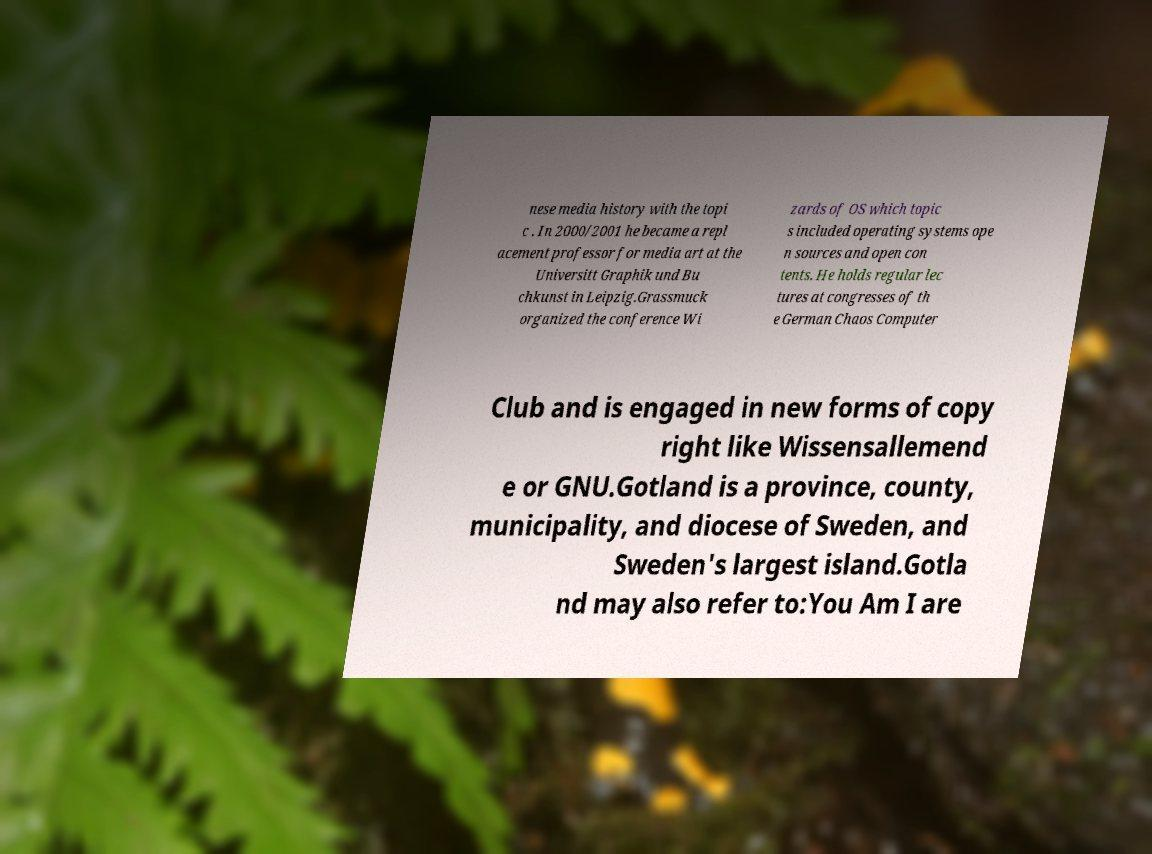What messages or text are displayed in this image? I need them in a readable, typed format. nese media history with the topi c . In 2000/2001 he became a repl acement professor for media art at the Universitt Graphik und Bu chkunst in Leipzig.Grassmuck organized the conference Wi zards of OS which topic s included operating systems ope n sources and open con tents. He holds regular lec tures at congresses of th e German Chaos Computer Club and is engaged in new forms of copy right like Wissensallemend e or GNU.Gotland is a province, county, municipality, and diocese of Sweden, and Sweden's largest island.Gotla nd may also refer to:You Am I are 